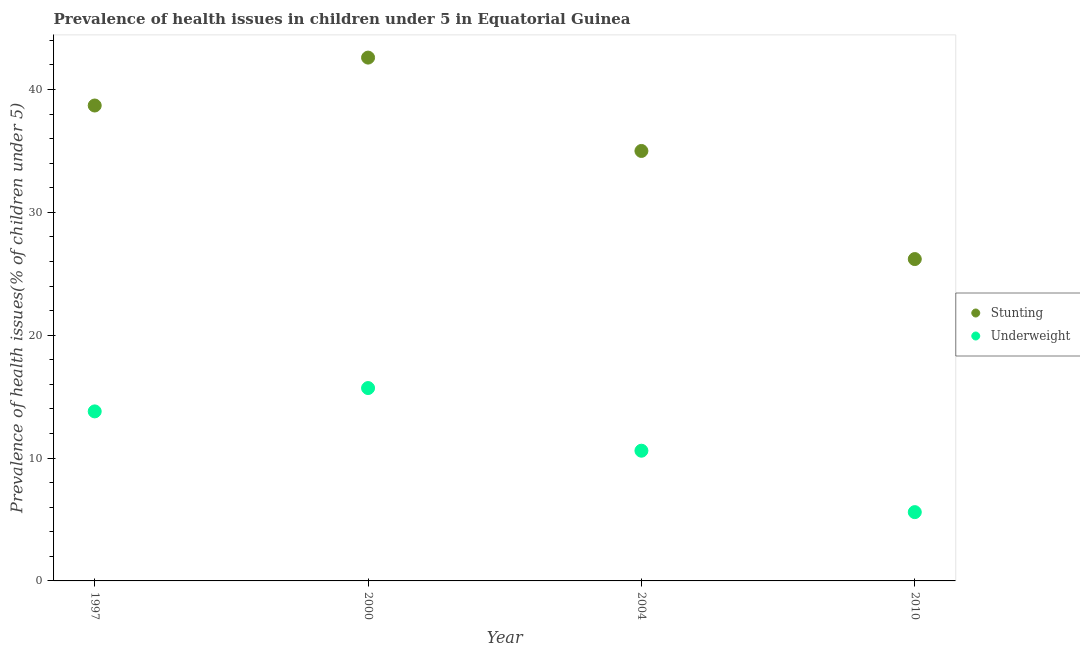How many different coloured dotlines are there?
Your answer should be very brief. 2. Is the number of dotlines equal to the number of legend labels?
Your answer should be very brief. Yes. Across all years, what is the maximum percentage of underweight children?
Provide a short and direct response. 15.7. Across all years, what is the minimum percentage of stunted children?
Keep it short and to the point. 26.2. What is the total percentage of stunted children in the graph?
Provide a succinct answer. 142.5. What is the difference between the percentage of stunted children in 1997 and that in 2010?
Offer a terse response. 12.5. What is the difference between the percentage of underweight children in 1997 and the percentage of stunted children in 2000?
Ensure brevity in your answer.  -28.8. What is the average percentage of underweight children per year?
Ensure brevity in your answer.  11.43. In the year 2010, what is the difference between the percentage of stunted children and percentage of underweight children?
Your answer should be very brief. 20.6. In how many years, is the percentage of stunted children greater than 10 %?
Give a very brief answer. 4. What is the ratio of the percentage of stunted children in 2000 to that in 2010?
Make the answer very short. 1.63. What is the difference between the highest and the second highest percentage of underweight children?
Your response must be concise. 1.9. What is the difference between the highest and the lowest percentage of underweight children?
Provide a succinct answer. 10.1. Is the percentage of stunted children strictly greater than the percentage of underweight children over the years?
Ensure brevity in your answer.  Yes. Is the percentage of underweight children strictly less than the percentage of stunted children over the years?
Give a very brief answer. Yes. How many years are there in the graph?
Offer a terse response. 4. Does the graph contain grids?
Keep it short and to the point. No. Where does the legend appear in the graph?
Provide a succinct answer. Center right. What is the title of the graph?
Your response must be concise. Prevalence of health issues in children under 5 in Equatorial Guinea. Does "Foreign liabilities" appear as one of the legend labels in the graph?
Provide a succinct answer. No. What is the label or title of the X-axis?
Your answer should be compact. Year. What is the label or title of the Y-axis?
Provide a succinct answer. Prevalence of health issues(% of children under 5). What is the Prevalence of health issues(% of children under 5) in Stunting in 1997?
Your answer should be very brief. 38.7. What is the Prevalence of health issues(% of children under 5) of Underweight in 1997?
Your answer should be compact. 13.8. What is the Prevalence of health issues(% of children under 5) of Stunting in 2000?
Provide a short and direct response. 42.6. What is the Prevalence of health issues(% of children under 5) in Underweight in 2000?
Offer a very short reply. 15.7. What is the Prevalence of health issues(% of children under 5) of Stunting in 2004?
Make the answer very short. 35. What is the Prevalence of health issues(% of children under 5) in Underweight in 2004?
Your answer should be compact. 10.6. What is the Prevalence of health issues(% of children under 5) of Stunting in 2010?
Your answer should be very brief. 26.2. What is the Prevalence of health issues(% of children under 5) in Underweight in 2010?
Keep it short and to the point. 5.6. Across all years, what is the maximum Prevalence of health issues(% of children under 5) of Stunting?
Your answer should be very brief. 42.6. Across all years, what is the maximum Prevalence of health issues(% of children under 5) of Underweight?
Provide a short and direct response. 15.7. Across all years, what is the minimum Prevalence of health issues(% of children under 5) in Stunting?
Provide a short and direct response. 26.2. Across all years, what is the minimum Prevalence of health issues(% of children under 5) in Underweight?
Your answer should be compact. 5.6. What is the total Prevalence of health issues(% of children under 5) of Stunting in the graph?
Keep it short and to the point. 142.5. What is the total Prevalence of health issues(% of children under 5) in Underweight in the graph?
Ensure brevity in your answer.  45.7. What is the difference between the Prevalence of health issues(% of children under 5) of Underweight in 1997 and that in 2000?
Offer a terse response. -1.9. What is the difference between the Prevalence of health issues(% of children under 5) of Stunting in 1997 and that in 2004?
Make the answer very short. 3.7. What is the difference between the Prevalence of health issues(% of children under 5) of Underweight in 1997 and that in 2004?
Offer a very short reply. 3.2. What is the difference between the Prevalence of health issues(% of children under 5) of Underweight in 1997 and that in 2010?
Your answer should be compact. 8.2. What is the difference between the Prevalence of health issues(% of children under 5) in Stunting in 2000 and that in 2004?
Give a very brief answer. 7.6. What is the difference between the Prevalence of health issues(% of children under 5) of Underweight in 2004 and that in 2010?
Keep it short and to the point. 5. What is the difference between the Prevalence of health issues(% of children under 5) in Stunting in 1997 and the Prevalence of health issues(% of children under 5) in Underweight in 2004?
Your response must be concise. 28.1. What is the difference between the Prevalence of health issues(% of children under 5) of Stunting in 1997 and the Prevalence of health issues(% of children under 5) of Underweight in 2010?
Your answer should be very brief. 33.1. What is the difference between the Prevalence of health issues(% of children under 5) of Stunting in 2000 and the Prevalence of health issues(% of children under 5) of Underweight in 2010?
Your response must be concise. 37. What is the difference between the Prevalence of health issues(% of children under 5) of Stunting in 2004 and the Prevalence of health issues(% of children under 5) of Underweight in 2010?
Give a very brief answer. 29.4. What is the average Prevalence of health issues(% of children under 5) of Stunting per year?
Your response must be concise. 35.62. What is the average Prevalence of health issues(% of children under 5) in Underweight per year?
Make the answer very short. 11.43. In the year 1997, what is the difference between the Prevalence of health issues(% of children under 5) in Stunting and Prevalence of health issues(% of children under 5) in Underweight?
Ensure brevity in your answer.  24.9. In the year 2000, what is the difference between the Prevalence of health issues(% of children under 5) of Stunting and Prevalence of health issues(% of children under 5) of Underweight?
Offer a terse response. 26.9. In the year 2004, what is the difference between the Prevalence of health issues(% of children under 5) of Stunting and Prevalence of health issues(% of children under 5) of Underweight?
Your response must be concise. 24.4. In the year 2010, what is the difference between the Prevalence of health issues(% of children under 5) in Stunting and Prevalence of health issues(% of children under 5) in Underweight?
Provide a short and direct response. 20.6. What is the ratio of the Prevalence of health issues(% of children under 5) of Stunting in 1997 to that in 2000?
Your answer should be very brief. 0.91. What is the ratio of the Prevalence of health issues(% of children under 5) in Underweight in 1997 to that in 2000?
Offer a terse response. 0.88. What is the ratio of the Prevalence of health issues(% of children under 5) of Stunting in 1997 to that in 2004?
Make the answer very short. 1.11. What is the ratio of the Prevalence of health issues(% of children under 5) of Underweight in 1997 to that in 2004?
Provide a succinct answer. 1.3. What is the ratio of the Prevalence of health issues(% of children under 5) in Stunting in 1997 to that in 2010?
Make the answer very short. 1.48. What is the ratio of the Prevalence of health issues(% of children under 5) in Underweight in 1997 to that in 2010?
Give a very brief answer. 2.46. What is the ratio of the Prevalence of health issues(% of children under 5) in Stunting in 2000 to that in 2004?
Your response must be concise. 1.22. What is the ratio of the Prevalence of health issues(% of children under 5) in Underweight in 2000 to that in 2004?
Keep it short and to the point. 1.48. What is the ratio of the Prevalence of health issues(% of children under 5) in Stunting in 2000 to that in 2010?
Your answer should be very brief. 1.63. What is the ratio of the Prevalence of health issues(% of children under 5) in Underweight in 2000 to that in 2010?
Offer a very short reply. 2.8. What is the ratio of the Prevalence of health issues(% of children under 5) of Stunting in 2004 to that in 2010?
Provide a succinct answer. 1.34. What is the ratio of the Prevalence of health issues(% of children under 5) in Underweight in 2004 to that in 2010?
Ensure brevity in your answer.  1.89. What is the difference between the highest and the second highest Prevalence of health issues(% of children under 5) of Stunting?
Ensure brevity in your answer.  3.9. What is the difference between the highest and the second highest Prevalence of health issues(% of children under 5) of Underweight?
Provide a short and direct response. 1.9. What is the difference between the highest and the lowest Prevalence of health issues(% of children under 5) in Stunting?
Keep it short and to the point. 16.4. 